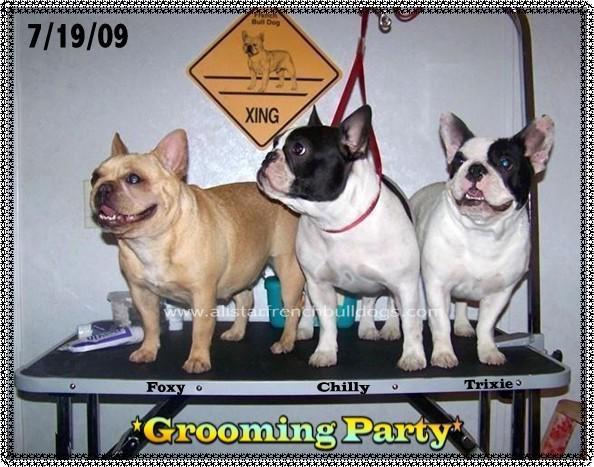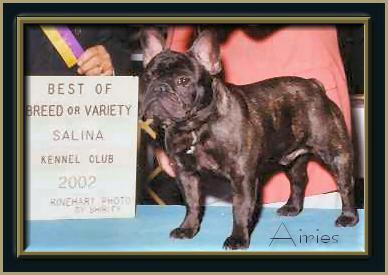The first image is the image on the left, the second image is the image on the right. Given the left and right images, does the statement "The left image features one standing buff-beige bulldog, and the right image contains one standing white bulldog who is gazing at the camera." hold true? Answer yes or no. No. The first image is the image on the left, the second image is the image on the right. Given the left and right images, does the statement "Two French Bulldogs are being held on a leash by a human." hold true? Answer yes or no. No. 